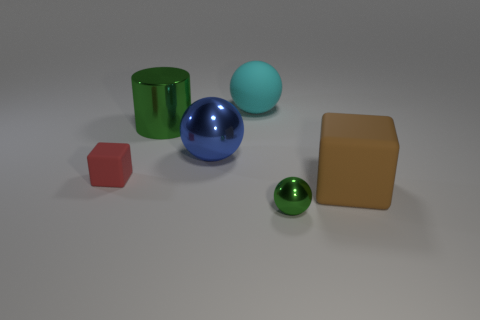Add 2 shiny objects. How many objects exist? 8 Subtract all cubes. How many objects are left? 4 Add 2 large blue matte things. How many large blue matte things exist? 2 Subtract 0 purple spheres. How many objects are left? 6 Subtract all small green matte objects. Subtract all tiny green spheres. How many objects are left? 5 Add 1 balls. How many balls are left? 4 